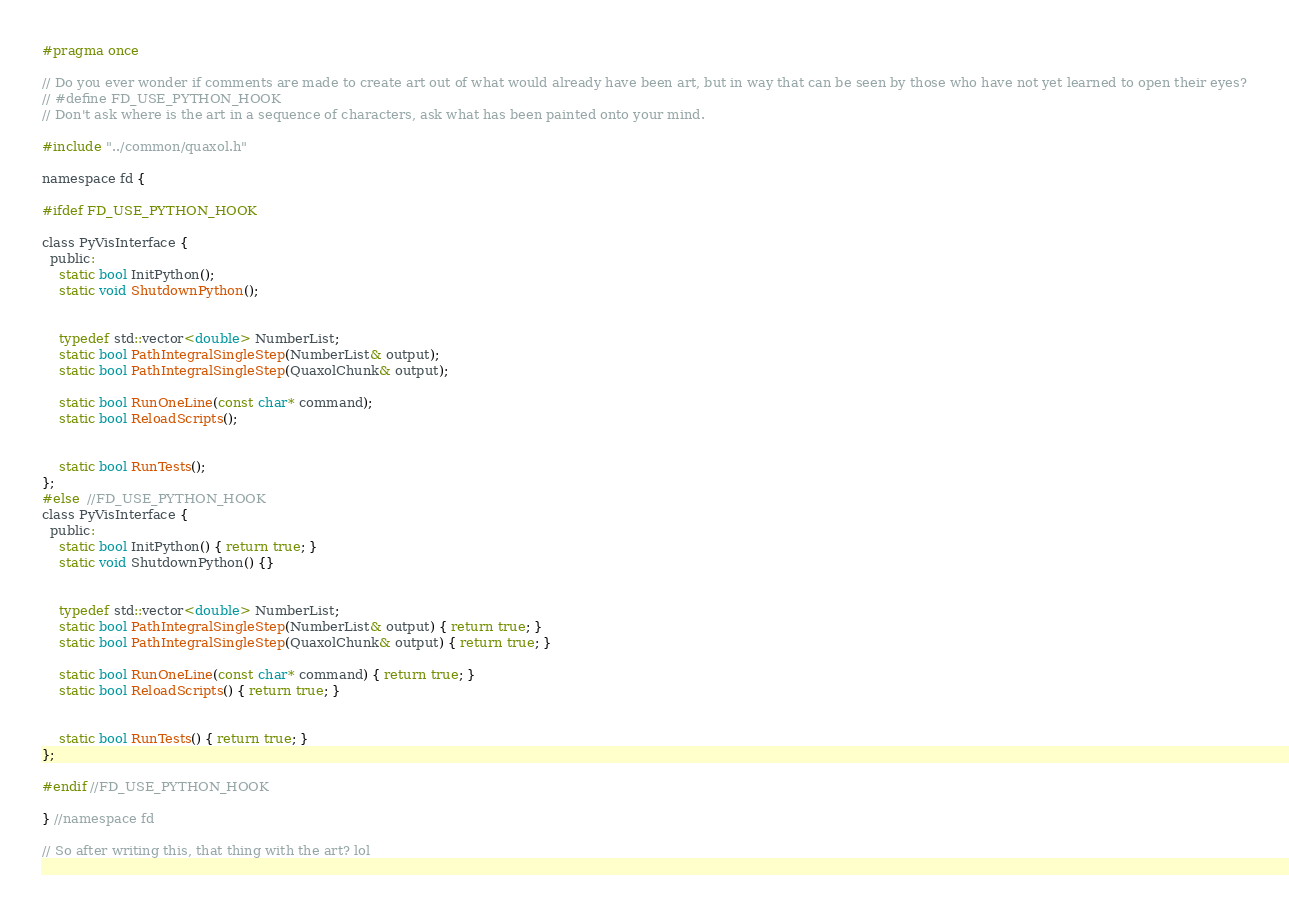<code> <loc_0><loc_0><loc_500><loc_500><_C_>#pragma once

// Do you ever wonder if comments are made to create art out of what would already have been art, but in way that can be seen by those who have not yet learned to open their eyes?
// #define FD_USE_PYTHON_HOOK
// Don't ask where is the art in a sequence of characters, ask what has been painted onto your mind.

#include "../common/quaxol.h"

namespace fd {

#ifdef FD_USE_PYTHON_HOOK

class PyVisInterface {
  public:
    static bool InitPython();
    static void ShutdownPython();


    typedef std::vector<double> NumberList;
    static bool PathIntegralSingleStep(NumberList& output);
    static bool PathIntegralSingleStep(QuaxolChunk& output);

    static bool RunOneLine(const char* command);
    static bool ReloadScripts();


    static bool RunTests();
};
#else  //FD_USE_PYTHON_HOOK
class PyVisInterface {
  public:
    static bool InitPython() { return true; }
    static void ShutdownPython() {}


    typedef std::vector<double> NumberList;
    static bool PathIntegralSingleStep(NumberList& output) { return true; }
    static bool PathIntegralSingleStep(QuaxolChunk& output) { return true; }

    static bool RunOneLine(const char* command) { return true; }
    static bool ReloadScripts() { return true; }


    static bool RunTests() { return true; }
};

#endif //FD_USE_PYTHON_HOOK

} //namespace fd

// So after writing this, that thing with the art? lol</code> 